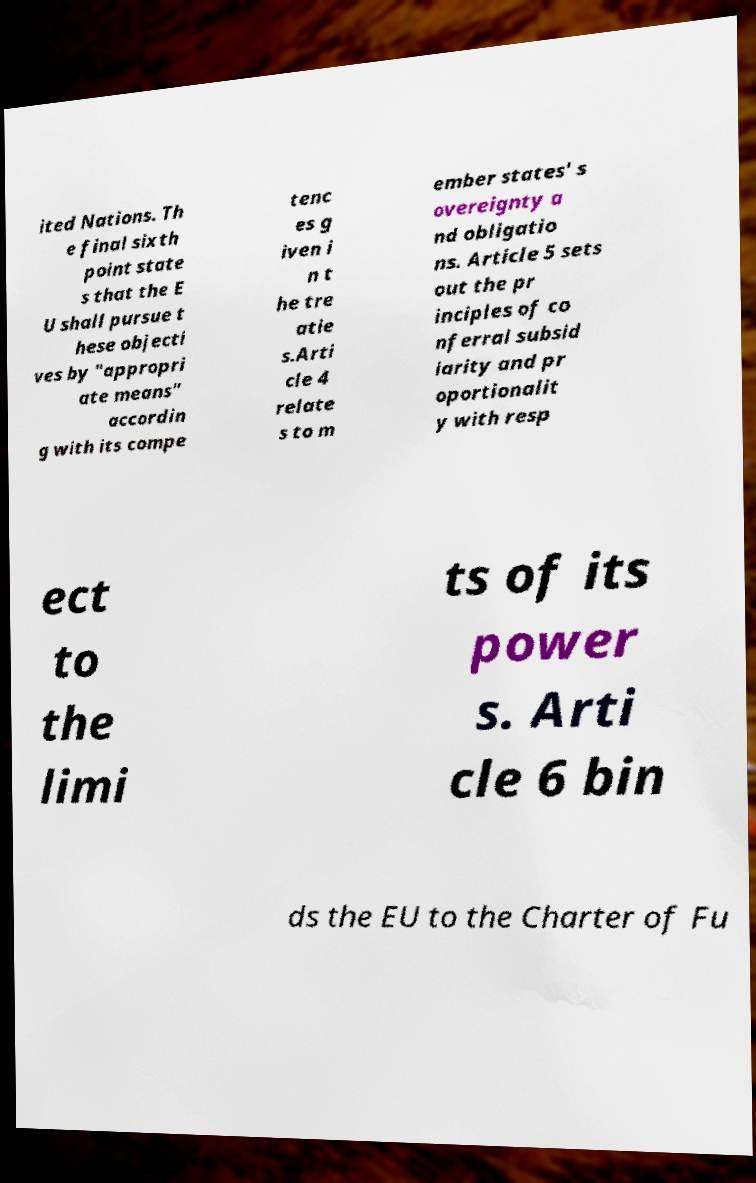There's text embedded in this image that I need extracted. Can you transcribe it verbatim? ited Nations. Th e final sixth point state s that the E U shall pursue t hese objecti ves by "appropri ate means" accordin g with its compe tenc es g iven i n t he tre atie s.Arti cle 4 relate s to m ember states' s overeignty a nd obligatio ns. Article 5 sets out the pr inciples of co nferral subsid iarity and pr oportionalit y with resp ect to the limi ts of its power s. Arti cle 6 bin ds the EU to the Charter of Fu 